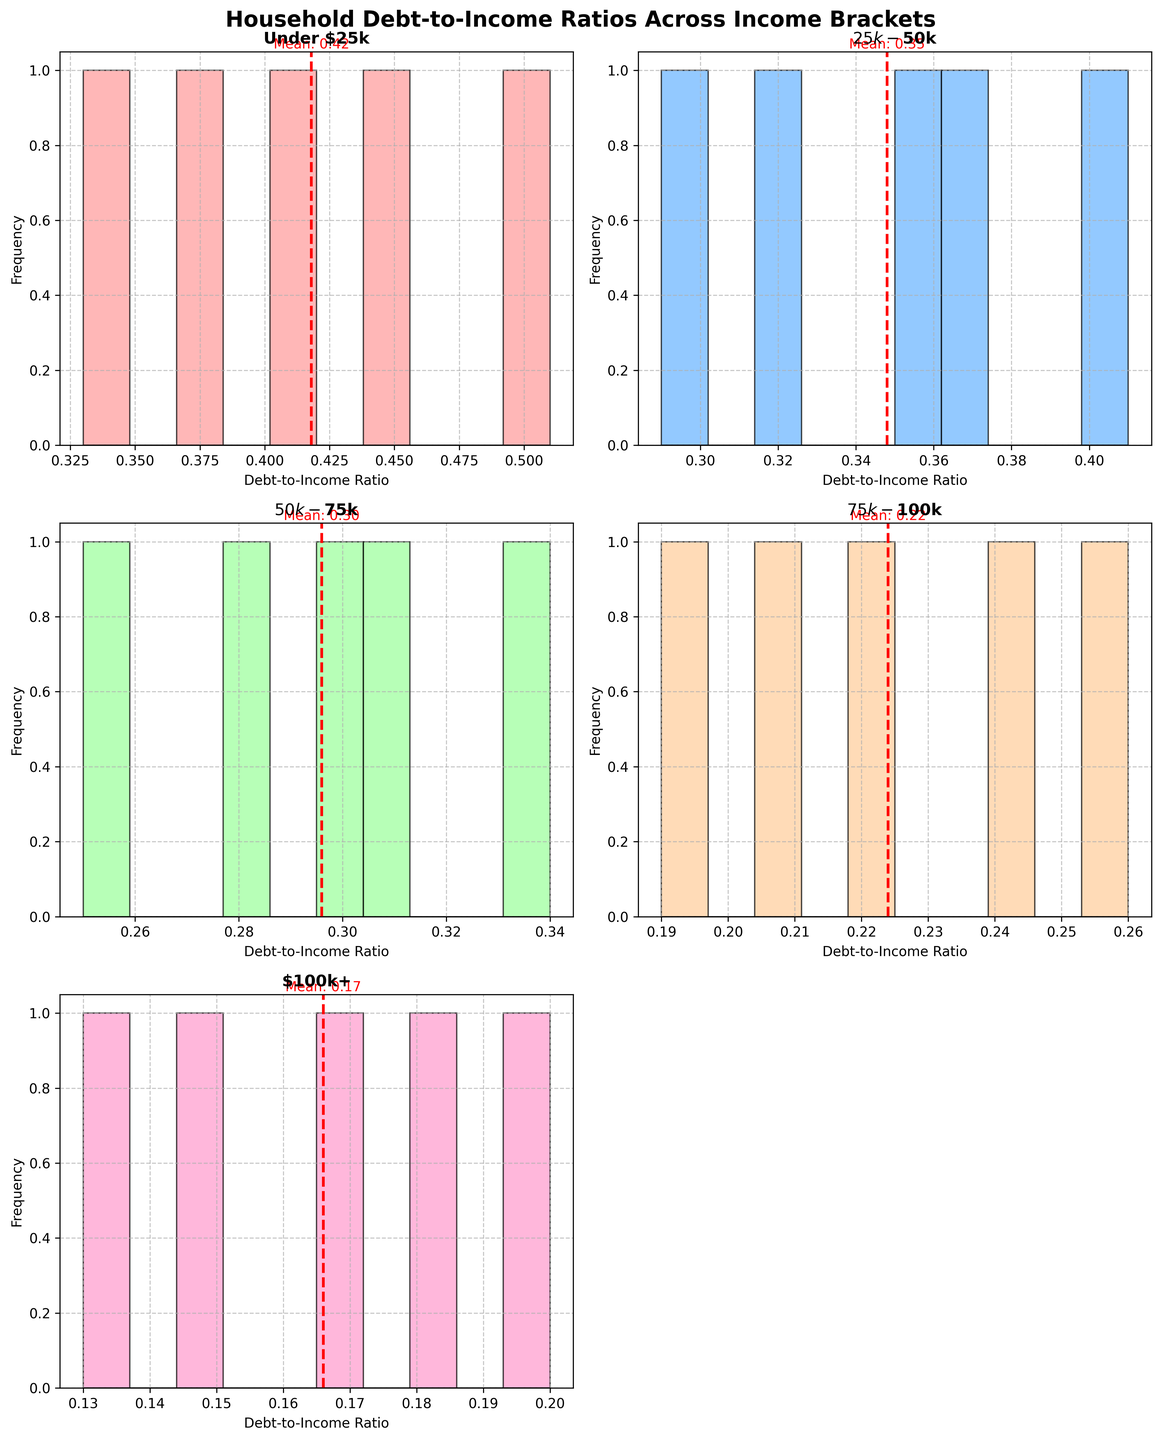What is the title of the figure? The title of the figure is usually displayed at the top and explains what the entire figure represents. In this case, it should be "Household Debt-to-Income Ratios Across Income Brackets" since that's the title set in the code.
Answer: Household Debt-to-Income Ratios Across Income Brackets What do the histograms in the figure represent? The histograms represent the distribution of household debt-to-income ratios for different income brackets. Each subplot shows a histogram for a specific income bracket, indicating how frequently each debt-to-income ratio occurs within that bracket.
Answer: Distribution of household debt-to-income ratios for different income brackets Which income bracket has the lowest average debt-to-income ratio? To determine the income bracket with the lowest average debt-to-income ratio, look for the histogram where the mean (indicated by a dashed red line) is lowest. The $100k+ bracket has the mean line positioned at the lowest value.
Answer: $100k+ How many income brackets are displayed in the figure? Each subplot represents an income bracket, and we need to count them. There are five unique brackets, but only five out of six subplot spaces are used, making it five income brackets displayed.
Answer: Five Which income bracket has the most spread-out debt-to-income ratios? To find the most spread-out distribution, look for the histogram with the widest range of values. The width can be inferred from the spread of bars along the x-axis. The "Under $25k" bracket appears to have the widest range.
Answer: Under $25k What does the dashed red line in each subplot represent? The dashed red line is a visual indicator for the mean debt-to-income ratio within each income bracket. It shows where the average ratio falls within the distribution.
Answer: Mean debt-to-income ratio Which income bracket has the most concentrated debt-to-income ratios around its mean? A concentrated distribution will have most bars located close to the red dashed line. The "$75k-$100k" bracket has a narrow spread with most values clustered around its mean.
Answer: $75k-$100k Which income bracket has the highest observed debt-to-income ratio? The highest observed debt-to-income ratio would be the rightmost bar across all histograms. The "Under $25k" bracket has the highest observed ratio close to 0.51.
Answer: Under $25k Compare the mean debt-to-income ratios between the "$50k-$75k" and "$25k-$50k" brackets. Which one is higher? Compare the positions of the dashed red lines for these two income brackets. The line for "$25k-$50k" is higher than that for "$50k-$75k", indicating a higher mean debt-to-income ratio.
Answer: $25k-$50k 